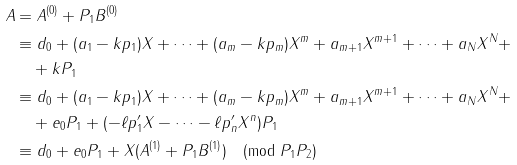<formula> <loc_0><loc_0><loc_500><loc_500>A & = A ^ { ( 0 ) } + P _ { 1 } B ^ { ( 0 ) } \\ & \equiv d _ { 0 } + ( a _ { 1 } - k p _ { 1 } ) X + \cdots + ( a _ { m } - k p _ { m } ) X ^ { m } + a _ { m + 1 } X ^ { m + 1 } + \cdots + a _ { N } X ^ { N } + \\ & \quad + k P _ { 1 } \\ & \equiv d _ { 0 } + ( a _ { 1 } - k p _ { 1 } ) X + \cdots + ( a _ { m } - k p _ { m } ) X ^ { m } + a _ { m + 1 } X ^ { m + 1 } + \cdots + a _ { N } X ^ { N } + \\ & \quad + e _ { 0 } P _ { 1 } + ( - \ell p ^ { \prime } _ { 1 } X - \cdots - \ell p ^ { \prime } _ { n } X ^ { n } ) P _ { 1 } \\ & \equiv d _ { 0 } + e _ { 0 } P _ { 1 } + X ( A ^ { ( 1 ) } + P _ { 1 } B ^ { ( 1 ) } ) \pmod { P _ { 1 } P _ { 2 } }</formula> 